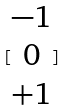Convert formula to latex. <formula><loc_0><loc_0><loc_500><loc_500>[ \begin{matrix} - 1 \\ 0 \\ + 1 \end{matrix} ]</formula> 